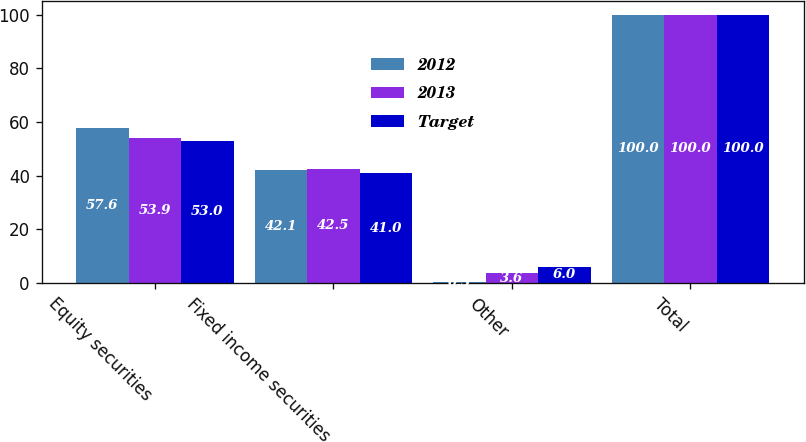Convert chart to OTSL. <chart><loc_0><loc_0><loc_500><loc_500><stacked_bar_chart><ecel><fcel>Equity securities<fcel>Fixed income securities<fcel>Other<fcel>Total<nl><fcel>2012<fcel>57.6<fcel>42.1<fcel>0.3<fcel>100<nl><fcel>2013<fcel>53.9<fcel>42.5<fcel>3.6<fcel>100<nl><fcel>Target<fcel>53<fcel>41<fcel>6<fcel>100<nl></chart> 